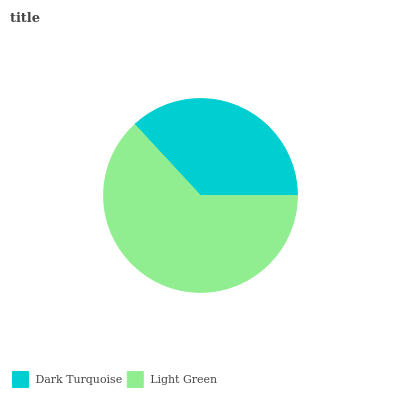Is Dark Turquoise the minimum?
Answer yes or no. Yes. Is Light Green the maximum?
Answer yes or no. Yes. Is Light Green the minimum?
Answer yes or no. No. Is Light Green greater than Dark Turquoise?
Answer yes or no. Yes. Is Dark Turquoise less than Light Green?
Answer yes or no. Yes. Is Dark Turquoise greater than Light Green?
Answer yes or no. No. Is Light Green less than Dark Turquoise?
Answer yes or no. No. Is Light Green the high median?
Answer yes or no. Yes. Is Dark Turquoise the low median?
Answer yes or no. Yes. Is Dark Turquoise the high median?
Answer yes or no. No. Is Light Green the low median?
Answer yes or no. No. 